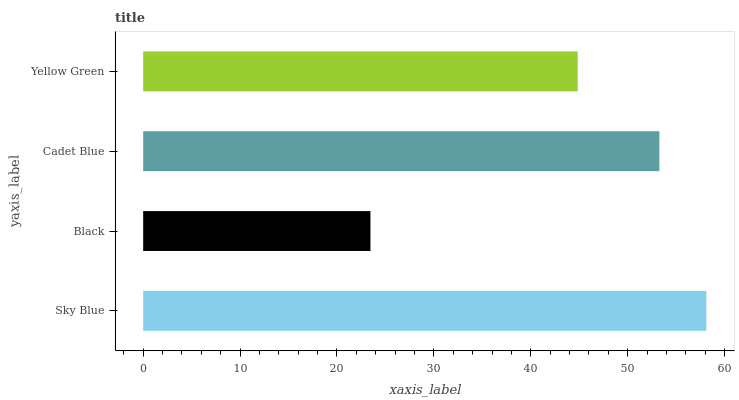Is Black the minimum?
Answer yes or no. Yes. Is Sky Blue the maximum?
Answer yes or no. Yes. Is Cadet Blue the minimum?
Answer yes or no. No. Is Cadet Blue the maximum?
Answer yes or no. No. Is Cadet Blue greater than Black?
Answer yes or no. Yes. Is Black less than Cadet Blue?
Answer yes or no. Yes. Is Black greater than Cadet Blue?
Answer yes or no. No. Is Cadet Blue less than Black?
Answer yes or no. No. Is Cadet Blue the high median?
Answer yes or no. Yes. Is Yellow Green the low median?
Answer yes or no. Yes. Is Sky Blue the high median?
Answer yes or no. No. Is Sky Blue the low median?
Answer yes or no. No. 